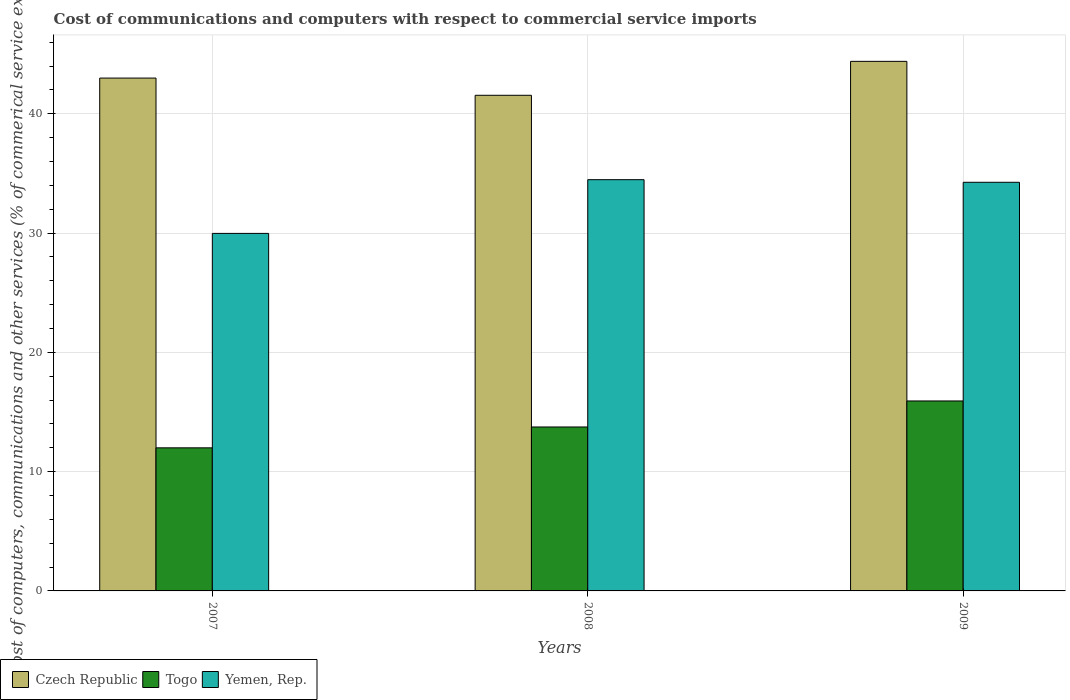How many different coloured bars are there?
Provide a succinct answer. 3. How many groups of bars are there?
Provide a succinct answer. 3. Are the number of bars per tick equal to the number of legend labels?
Give a very brief answer. Yes. What is the label of the 2nd group of bars from the left?
Keep it short and to the point. 2008. What is the cost of communications and computers in Togo in 2009?
Keep it short and to the point. 15.93. Across all years, what is the maximum cost of communications and computers in Yemen, Rep.?
Offer a terse response. 34.47. Across all years, what is the minimum cost of communications and computers in Czech Republic?
Offer a terse response. 41.55. In which year was the cost of communications and computers in Yemen, Rep. maximum?
Offer a very short reply. 2008. In which year was the cost of communications and computers in Czech Republic minimum?
Keep it short and to the point. 2008. What is the total cost of communications and computers in Togo in the graph?
Provide a succinct answer. 41.66. What is the difference between the cost of communications and computers in Yemen, Rep. in 2007 and that in 2009?
Your answer should be compact. -4.29. What is the difference between the cost of communications and computers in Yemen, Rep. in 2008 and the cost of communications and computers in Togo in 2009?
Your answer should be compact. 18.55. What is the average cost of communications and computers in Yemen, Rep. per year?
Your response must be concise. 32.9. In the year 2007, what is the difference between the cost of communications and computers in Yemen, Rep. and cost of communications and computers in Czech Republic?
Your response must be concise. -13.02. What is the ratio of the cost of communications and computers in Togo in 2007 to that in 2009?
Provide a succinct answer. 0.75. Is the cost of communications and computers in Czech Republic in 2008 less than that in 2009?
Your response must be concise. Yes. Is the difference between the cost of communications and computers in Yemen, Rep. in 2008 and 2009 greater than the difference between the cost of communications and computers in Czech Republic in 2008 and 2009?
Make the answer very short. Yes. What is the difference between the highest and the second highest cost of communications and computers in Czech Republic?
Give a very brief answer. 1.4. What is the difference between the highest and the lowest cost of communications and computers in Czech Republic?
Ensure brevity in your answer.  2.84. Is the sum of the cost of communications and computers in Yemen, Rep. in 2007 and 2008 greater than the maximum cost of communications and computers in Togo across all years?
Provide a short and direct response. Yes. What does the 2nd bar from the left in 2008 represents?
Ensure brevity in your answer.  Togo. What does the 1st bar from the right in 2008 represents?
Offer a very short reply. Yemen, Rep. How many bars are there?
Provide a short and direct response. 9. Are all the bars in the graph horizontal?
Your answer should be very brief. No. How many years are there in the graph?
Provide a succinct answer. 3. What is the difference between two consecutive major ticks on the Y-axis?
Your response must be concise. 10. Does the graph contain any zero values?
Provide a succinct answer. No. Does the graph contain grids?
Keep it short and to the point. Yes. Where does the legend appear in the graph?
Your response must be concise. Bottom left. How are the legend labels stacked?
Keep it short and to the point. Horizontal. What is the title of the graph?
Offer a terse response. Cost of communications and computers with respect to commercial service imports. What is the label or title of the X-axis?
Offer a terse response. Years. What is the label or title of the Y-axis?
Provide a short and direct response. Cost of computers, communications and other services (% of commerical service exports). What is the Cost of computers, communications and other services (% of commerical service exports) in Czech Republic in 2007?
Ensure brevity in your answer.  42.99. What is the Cost of computers, communications and other services (% of commerical service exports) of Togo in 2007?
Your answer should be compact. 11.99. What is the Cost of computers, communications and other services (% of commerical service exports) in Yemen, Rep. in 2007?
Your answer should be very brief. 29.97. What is the Cost of computers, communications and other services (% of commerical service exports) in Czech Republic in 2008?
Your answer should be compact. 41.55. What is the Cost of computers, communications and other services (% of commerical service exports) of Togo in 2008?
Provide a short and direct response. 13.74. What is the Cost of computers, communications and other services (% of commerical service exports) of Yemen, Rep. in 2008?
Your answer should be compact. 34.47. What is the Cost of computers, communications and other services (% of commerical service exports) of Czech Republic in 2009?
Offer a terse response. 44.39. What is the Cost of computers, communications and other services (% of commerical service exports) in Togo in 2009?
Provide a succinct answer. 15.93. What is the Cost of computers, communications and other services (% of commerical service exports) in Yemen, Rep. in 2009?
Provide a short and direct response. 34.26. Across all years, what is the maximum Cost of computers, communications and other services (% of commerical service exports) of Czech Republic?
Provide a short and direct response. 44.39. Across all years, what is the maximum Cost of computers, communications and other services (% of commerical service exports) in Togo?
Make the answer very short. 15.93. Across all years, what is the maximum Cost of computers, communications and other services (% of commerical service exports) in Yemen, Rep.?
Offer a terse response. 34.47. Across all years, what is the minimum Cost of computers, communications and other services (% of commerical service exports) of Czech Republic?
Make the answer very short. 41.55. Across all years, what is the minimum Cost of computers, communications and other services (% of commerical service exports) in Togo?
Offer a terse response. 11.99. Across all years, what is the minimum Cost of computers, communications and other services (% of commerical service exports) in Yemen, Rep.?
Keep it short and to the point. 29.97. What is the total Cost of computers, communications and other services (% of commerical service exports) of Czech Republic in the graph?
Make the answer very short. 128.93. What is the total Cost of computers, communications and other services (% of commerical service exports) of Togo in the graph?
Keep it short and to the point. 41.66. What is the total Cost of computers, communications and other services (% of commerical service exports) in Yemen, Rep. in the graph?
Make the answer very short. 98.7. What is the difference between the Cost of computers, communications and other services (% of commerical service exports) in Czech Republic in 2007 and that in 2008?
Provide a succinct answer. 1.44. What is the difference between the Cost of computers, communications and other services (% of commerical service exports) of Togo in 2007 and that in 2008?
Provide a succinct answer. -1.75. What is the difference between the Cost of computers, communications and other services (% of commerical service exports) in Yemen, Rep. in 2007 and that in 2008?
Provide a succinct answer. -4.5. What is the difference between the Cost of computers, communications and other services (% of commerical service exports) of Czech Republic in 2007 and that in 2009?
Ensure brevity in your answer.  -1.4. What is the difference between the Cost of computers, communications and other services (% of commerical service exports) of Togo in 2007 and that in 2009?
Offer a very short reply. -3.93. What is the difference between the Cost of computers, communications and other services (% of commerical service exports) in Yemen, Rep. in 2007 and that in 2009?
Provide a short and direct response. -4.29. What is the difference between the Cost of computers, communications and other services (% of commerical service exports) in Czech Republic in 2008 and that in 2009?
Your response must be concise. -2.84. What is the difference between the Cost of computers, communications and other services (% of commerical service exports) in Togo in 2008 and that in 2009?
Your response must be concise. -2.18. What is the difference between the Cost of computers, communications and other services (% of commerical service exports) of Yemen, Rep. in 2008 and that in 2009?
Your answer should be very brief. 0.22. What is the difference between the Cost of computers, communications and other services (% of commerical service exports) of Czech Republic in 2007 and the Cost of computers, communications and other services (% of commerical service exports) of Togo in 2008?
Provide a short and direct response. 29.25. What is the difference between the Cost of computers, communications and other services (% of commerical service exports) in Czech Republic in 2007 and the Cost of computers, communications and other services (% of commerical service exports) in Yemen, Rep. in 2008?
Your answer should be very brief. 8.52. What is the difference between the Cost of computers, communications and other services (% of commerical service exports) in Togo in 2007 and the Cost of computers, communications and other services (% of commerical service exports) in Yemen, Rep. in 2008?
Provide a succinct answer. -22.48. What is the difference between the Cost of computers, communications and other services (% of commerical service exports) of Czech Republic in 2007 and the Cost of computers, communications and other services (% of commerical service exports) of Togo in 2009?
Your response must be concise. 27.07. What is the difference between the Cost of computers, communications and other services (% of commerical service exports) in Czech Republic in 2007 and the Cost of computers, communications and other services (% of commerical service exports) in Yemen, Rep. in 2009?
Your response must be concise. 8.74. What is the difference between the Cost of computers, communications and other services (% of commerical service exports) of Togo in 2007 and the Cost of computers, communications and other services (% of commerical service exports) of Yemen, Rep. in 2009?
Make the answer very short. -22.26. What is the difference between the Cost of computers, communications and other services (% of commerical service exports) of Czech Republic in 2008 and the Cost of computers, communications and other services (% of commerical service exports) of Togo in 2009?
Give a very brief answer. 25.62. What is the difference between the Cost of computers, communications and other services (% of commerical service exports) of Czech Republic in 2008 and the Cost of computers, communications and other services (% of commerical service exports) of Yemen, Rep. in 2009?
Provide a succinct answer. 7.29. What is the difference between the Cost of computers, communications and other services (% of commerical service exports) in Togo in 2008 and the Cost of computers, communications and other services (% of commerical service exports) in Yemen, Rep. in 2009?
Offer a terse response. -20.51. What is the average Cost of computers, communications and other services (% of commerical service exports) in Czech Republic per year?
Provide a short and direct response. 42.98. What is the average Cost of computers, communications and other services (% of commerical service exports) in Togo per year?
Offer a terse response. 13.89. What is the average Cost of computers, communications and other services (% of commerical service exports) of Yemen, Rep. per year?
Offer a very short reply. 32.9. In the year 2007, what is the difference between the Cost of computers, communications and other services (% of commerical service exports) of Czech Republic and Cost of computers, communications and other services (% of commerical service exports) of Togo?
Offer a very short reply. 31. In the year 2007, what is the difference between the Cost of computers, communications and other services (% of commerical service exports) of Czech Republic and Cost of computers, communications and other services (% of commerical service exports) of Yemen, Rep.?
Make the answer very short. 13.02. In the year 2007, what is the difference between the Cost of computers, communications and other services (% of commerical service exports) in Togo and Cost of computers, communications and other services (% of commerical service exports) in Yemen, Rep.?
Your answer should be compact. -17.98. In the year 2008, what is the difference between the Cost of computers, communications and other services (% of commerical service exports) of Czech Republic and Cost of computers, communications and other services (% of commerical service exports) of Togo?
Provide a succinct answer. 27.81. In the year 2008, what is the difference between the Cost of computers, communications and other services (% of commerical service exports) of Czech Republic and Cost of computers, communications and other services (% of commerical service exports) of Yemen, Rep.?
Your answer should be compact. 7.07. In the year 2008, what is the difference between the Cost of computers, communications and other services (% of commerical service exports) in Togo and Cost of computers, communications and other services (% of commerical service exports) in Yemen, Rep.?
Your response must be concise. -20.73. In the year 2009, what is the difference between the Cost of computers, communications and other services (% of commerical service exports) of Czech Republic and Cost of computers, communications and other services (% of commerical service exports) of Togo?
Offer a terse response. 28.47. In the year 2009, what is the difference between the Cost of computers, communications and other services (% of commerical service exports) in Czech Republic and Cost of computers, communications and other services (% of commerical service exports) in Yemen, Rep.?
Offer a very short reply. 10.14. In the year 2009, what is the difference between the Cost of computers, communications and other services (% of commerical service exports) in Togo and Cost of computers, communications and other services (% of commerical service exports) in Yemen, Rep.?
Provide a short and direct response. -18.33. What is the ratio of the Cost of computers, communications and other services (% of commerical service exports) of Czech Republic in 2007 to that in 2008?
Offer a very short reply. 1.03. What is the ratio of the Cost of computers, communications and other services (% of commerical service exports) of Togo in 2007 to that in 2008?
Offer a very short reply. 0.87. What is the ratio of the Cost of computers, communications and other services (% of commerical service exports) in Yemen, Rep. in 2007 to that in 2008?
Your answer should be compact. 0.87. What is the ratio of the Cost of computers, communications and other services (% of commerical service exports) of Czech Republic in 2007 to that in 2009?
Your response must be concise. 0.97. What is the ratio of the Cost of computers, communications and other services (% of commerical service exports) of Togo in 2007 to that in 2009?
Provide a succinct answer. 0.75. What is the ratio of the Cost of computers, communications and other services (% of commerical service exports) in Yemen, Rep. in 2007 to that in 2009?
Provide a short and direct response. 0.87. What is the ratio of the Cost of computers, communications and other services (% of commerical service exports) in Czech Republic in 2008 to that in 2009?
Your answer should be very brief. 0.94. What is the ratio of the Cost of computers, communications and other services (% of commerical service exports) of Togo in 2008 to that in 2009?
Keep it short and to the point. 0.86. What is the ratio of the Cost of computers, communications and other services (% of commerical service exports) of Yemen, Rep. in 2008 to that in 2009?
Offer a very short reply. 1.01. What is the difference between the highest and the second highest Cost of computers, communications and other services (% of commerical service exports) in Czech Republic?
Your response must be concise. 1.4. What is the difference between the highest and the second highest Cost of computers, communications and other services (% of commerical service exports) in Togo?
Offer a terse response. 2.18. What is the difference between the highest and the second highest Cost of computers, communications and other services (% of commerical service exports) of Yemen, Rep.?
Provide a succinct answer. 0.22. What is the difference between the highest and the lowest Cost of computers, communications and other services (% of commerical service exports) of Czech Republic?
Your answer should be compact. 2.84. What is the difference between the highest and the lowest Cost of computers, communications and other services (% of commerical service exports) in Togo?
Offer a terse response. 3.93. What is the difference between the highest and the lowest Cost of computers, communications and other services (% of commerical service exports) in Yemen, Rep.?
Ensure brevity in your answer.  4.5. 